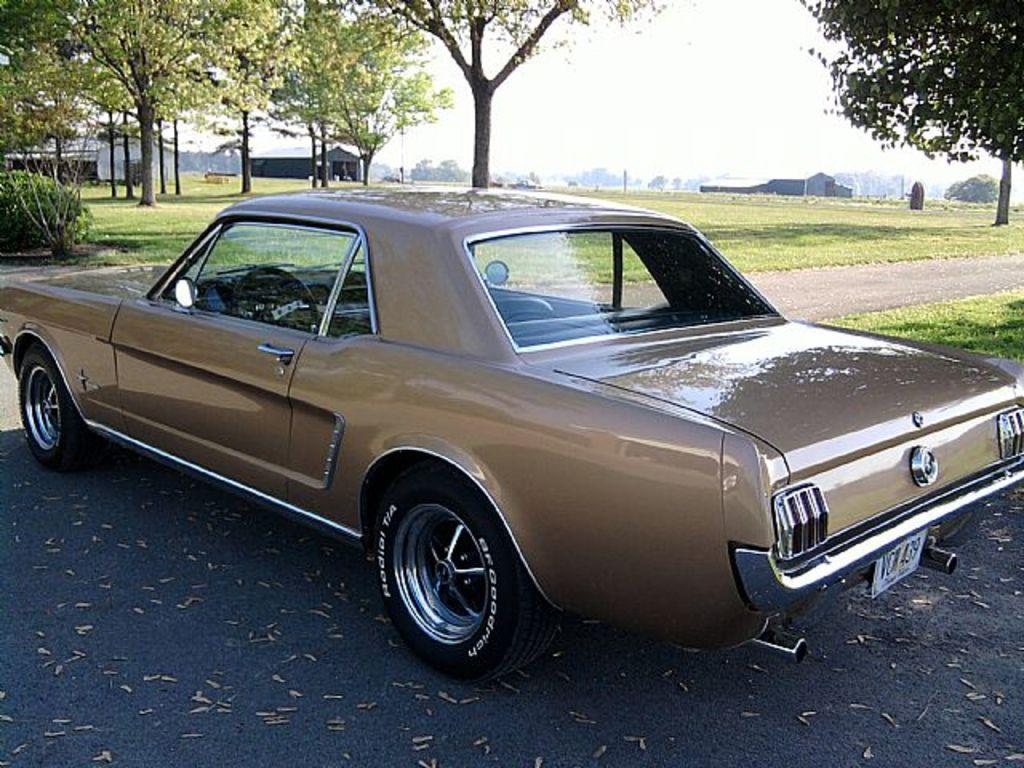What is the main subject of the image? There is a car in the image. Where is the car located? The car is placed on the road. What can be seen behind the car? There are tents behind the car. What type of natural environment is visible in the background of the image? There are trees, grass, and plants in the background of the image. What type of paste is being used to hold the car together in the image? There is no indication in the image that the car is being held together with paste, and therefore no such activity can be observed. 